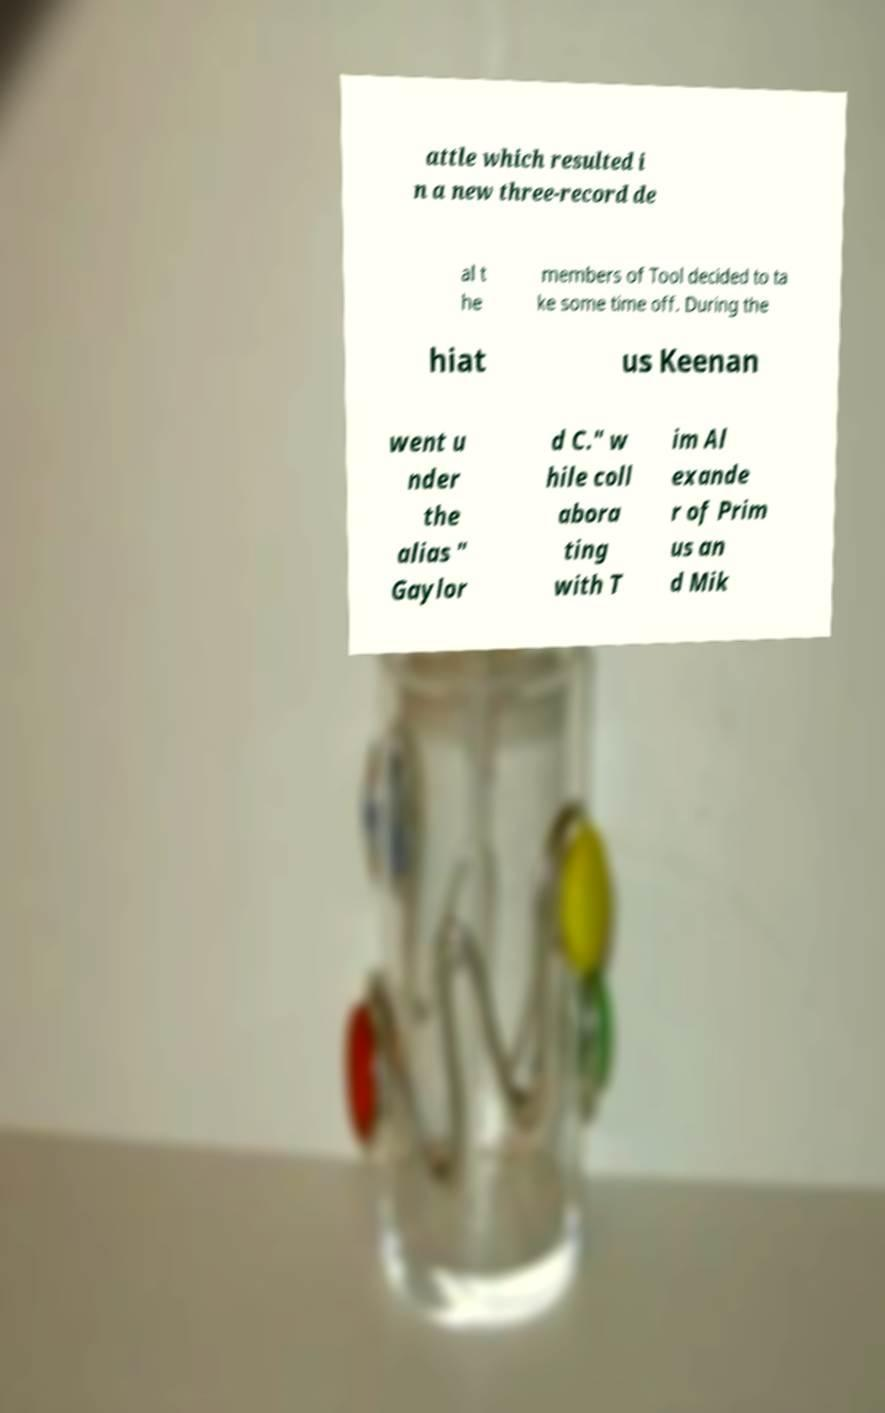Can you read and provide the text displayed in the image?This photo seems to have some interesting text. Can you extract and type it out for me? attle which resulted i n a new three-record de al t he members of Tool decided to ta ke some time off. During the hiat us Keenan went u nder the alias " Gaylor d C." w hile coll abora ting with T im Al exande r of Prim us an d Mik 